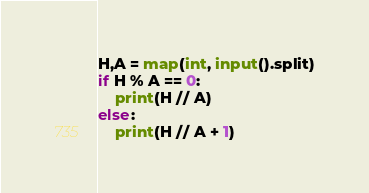Convert code to text. <code><loc_0><loc_0><loc_500><loc_500><_Python_>H,A = map(int, input().split)
if H % A == 0:
    print(H // A)
else:
    print(H // A + 1)</code> 